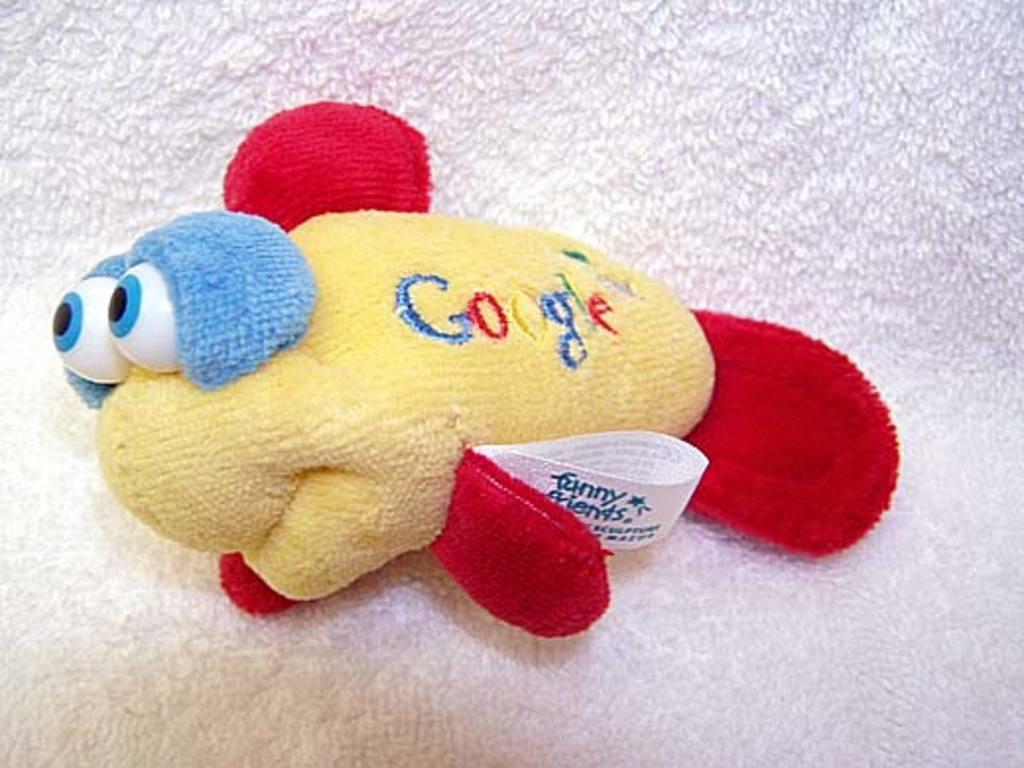How would you summarize this image in a sentence or two? In this picture I can see a toy of a fish on the cloth. 